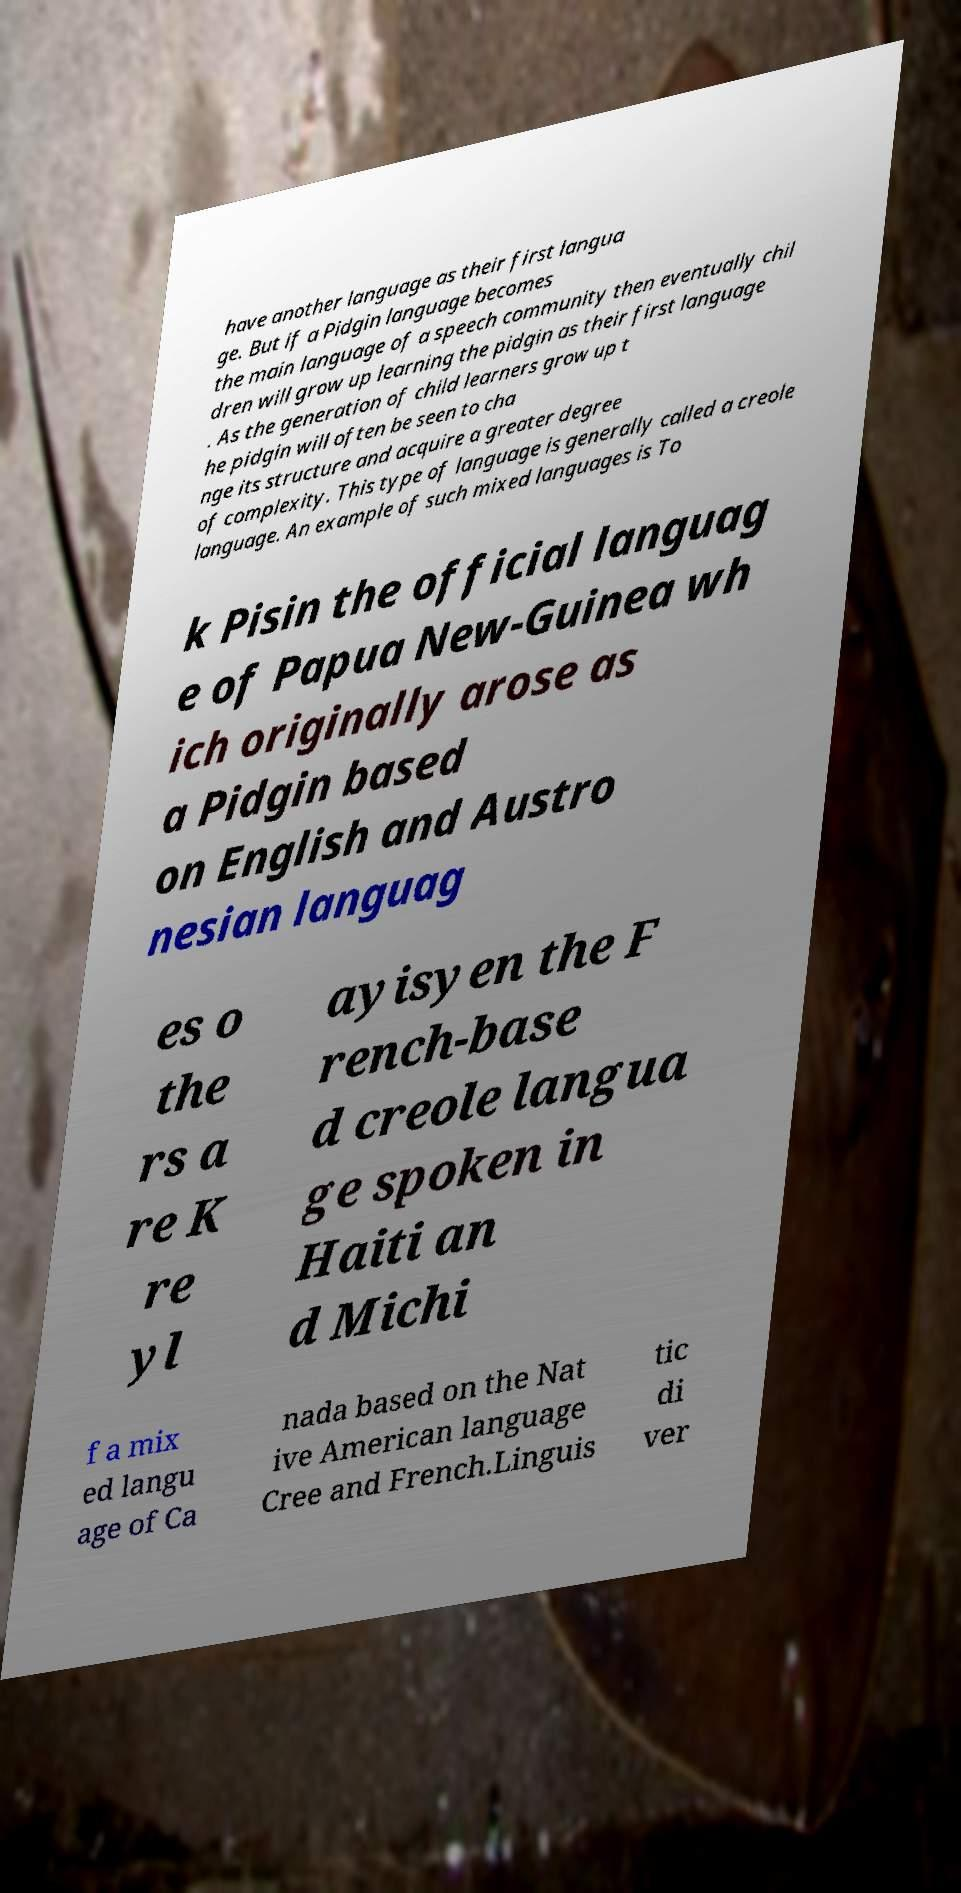Could you assist in decoding the text presented in this image and type it out clearly? have another language as their first langua ge. But if a Pidgin language becomes the main language of a speech community then eventually chil dren will grow up learning the pidgin as their first language . As the generation of child learners grow up t he pidgin will often be seen to cha nge its structure and acquire a greater degree of complexity. This type of language is generally called a creole language. An example of such mixed languages is To k Pisin the official languag e of Papua New-Guinea wh ich originally arose as a Pidgin based on English and Austro nesian languag es o the rs a re K re yl ayisyen the F rench-base d creole langua ge spoken in Haiti an d Michi f a mix ed langu age of Ca nada based on the Nat ive American language Cree and French.Linguis tic di ver 